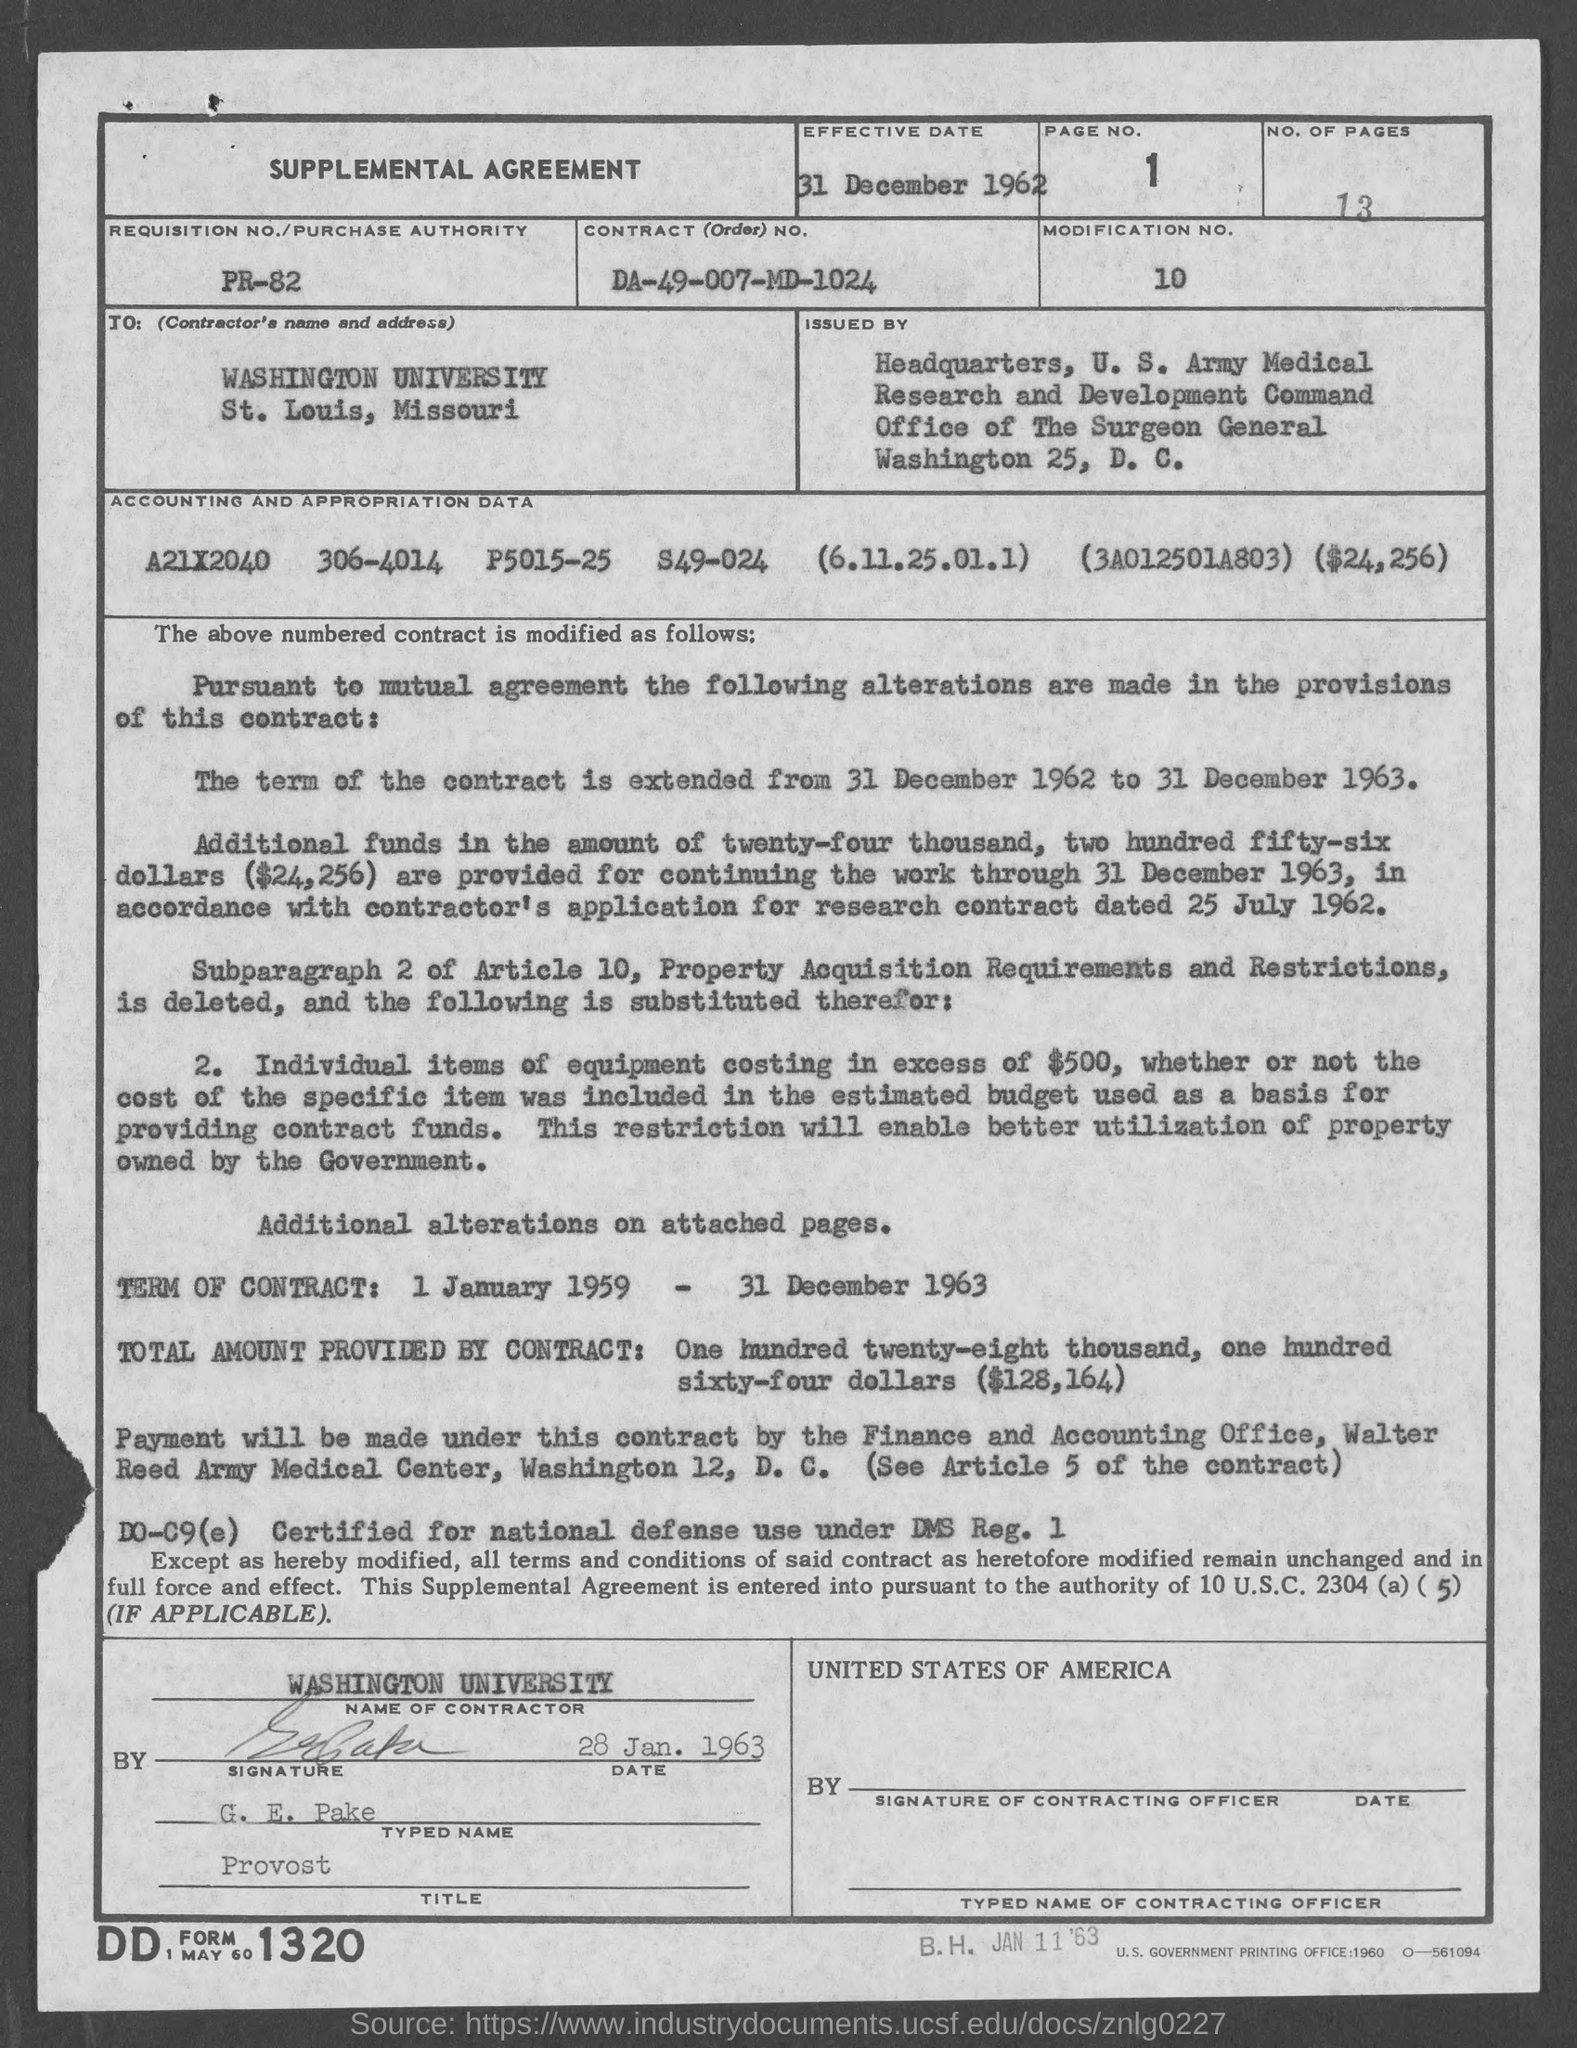Who is the contractor listed in this document, and what is their location? The contractor listed is 'WASHINGTON UNIVERSITY in St. Louis, Missouri.' Their details can be found in the top-left section of the document under 'TO: (Contractor's name and address).' What specific term of the contract is being extended, according to the document? The term of the contract is being extended from 1 January 1959 to 31 December 1963, which is clarified under the 'SUPPLEMENTAL AGREEMENT' as the duration of this contract's validity. 